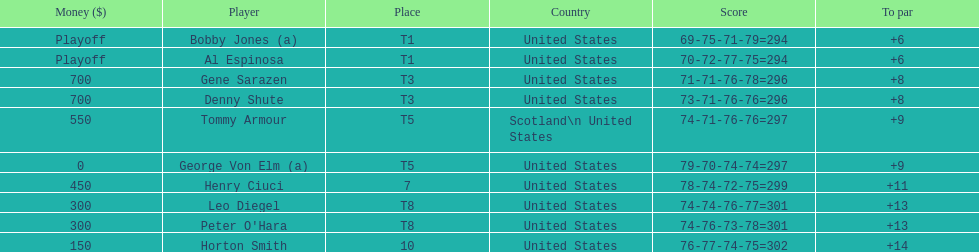How many players represented scotland? 1. 